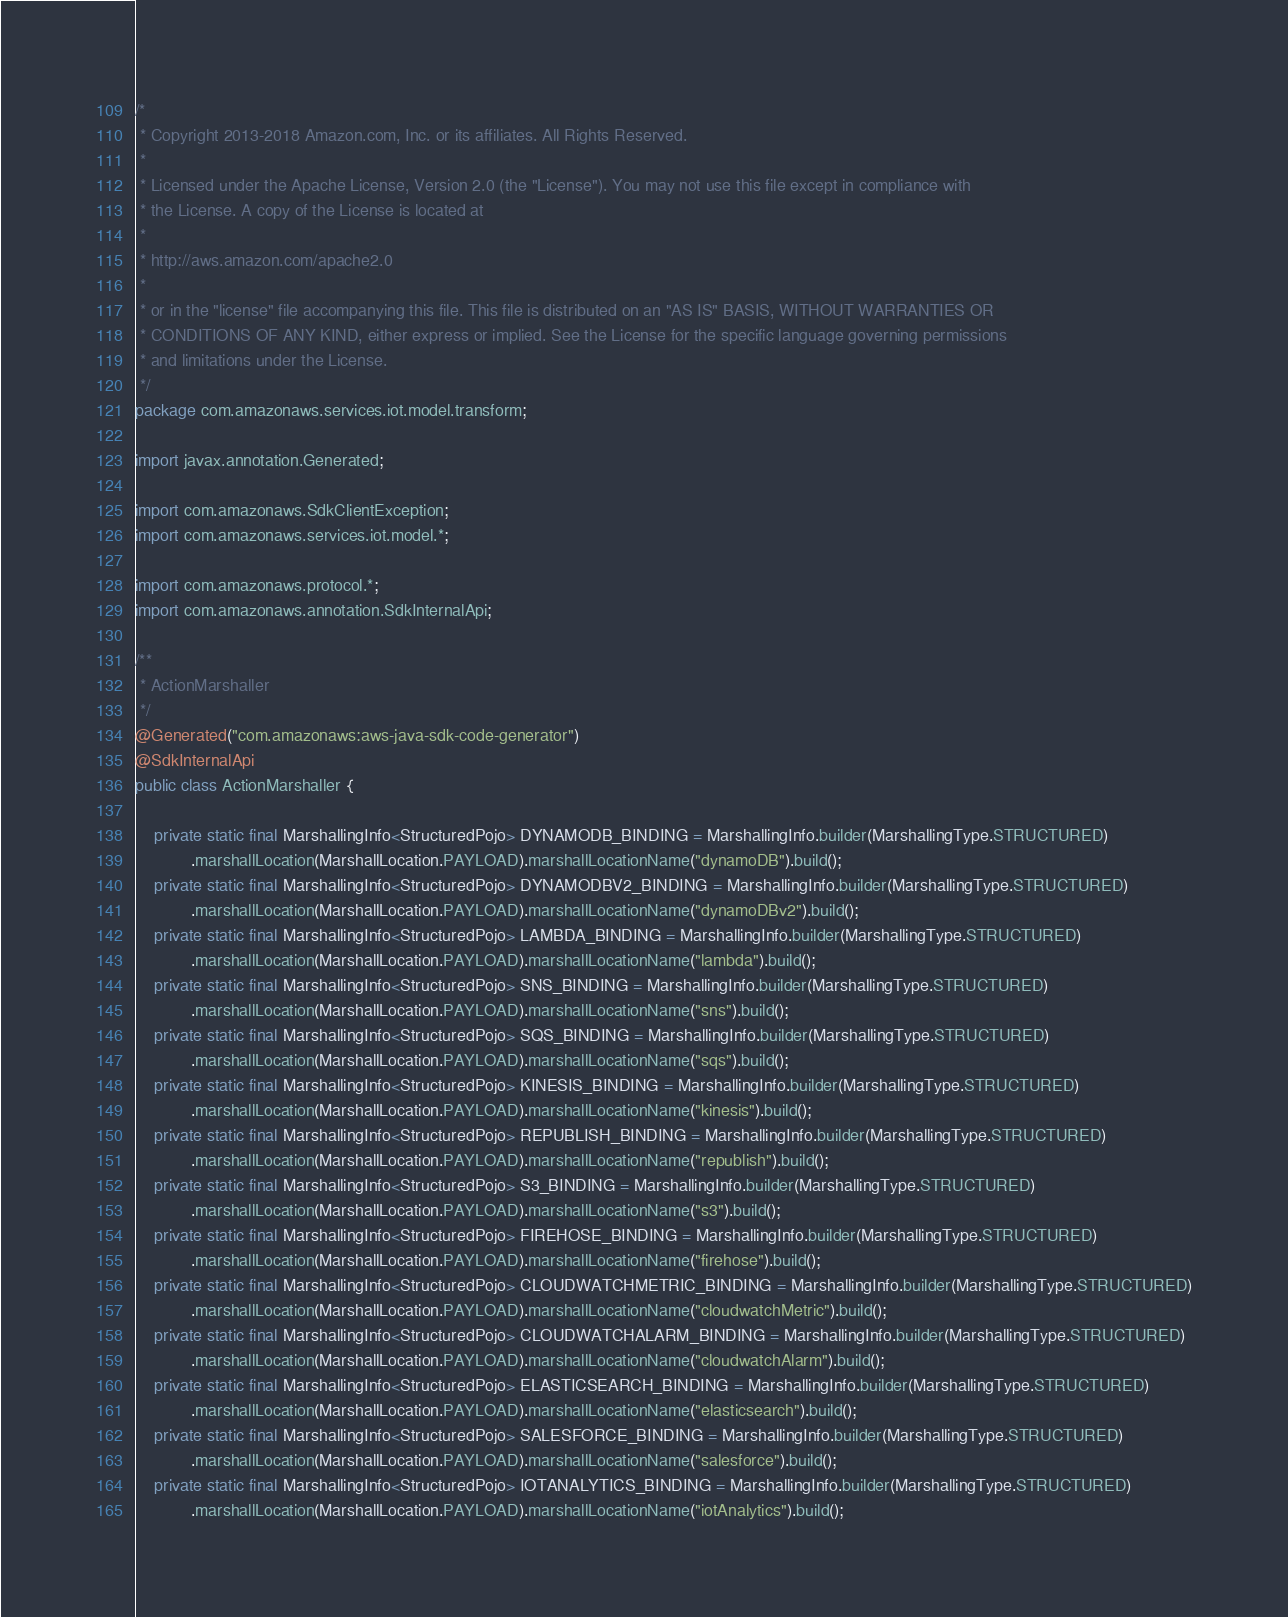Convert code to text. <code><loc_0><loc_0><loc_500><loc_500><_Java_>/*
 * Copyright 2013-2018 Amazon.com, Inc. or its affiliates. All Rights Reserved.
 * 
 * Licensed under the Apache License, Version 2.0 (the "License"). You may not use this file except in compliance with
 * the License. A copy of the License is located at
 * 
 * http://aws.amazon.com/apache2.0
 * 
 * or in the "license" file accompanying this file. This file is distributed on an "AS IS" BASIS, WITHOUT WARRANTIES OR
 * CONDITIONS OF ANY KIND, either express or implied. See the License for the specific language governing permissions
 * and limitations under the License.
 */
package com.amazonaws.services.iot.model.transform;

import javax.annotation.Generated;

import com.amazonaws.SdkClientException;
import com.amazonaws.services.iot.model.*;

import com.amazonaws.protocol.*;
import com.amazonaws.annotation.SdkInternalApi;

/**
 * ActionMarshaller
 */
@Generated("com.amazonaws:aws-java-sdk-code-generator")
@SdkInternalApi
public class ActionMarshaller {

    private static final MarshallingInfo<StructuredPojo> DYNAMODB_BINDING = MarshallingInfo.builder(MarshallingType.STRUCTURED)
            .marshallLocation(MarshallLocation.PAYLOAD).marshallLocationName("dynamoDB").build();
    private static final MarshallingInfo<StructuredPojo> DYNAMODBV2_BINDING = MarshallingInfo.builder(MarshallingType.STRUCTURED)
            .marshallLocation(MarshallLocation.PAYLOAD).marshallLocationName("dynamoDBv2").build();
    private static final MarshallingInfo<StructuredPojo> LAMBDA_BINDING = MarshallingInfo.builder(MarshallingType.STRUCTURED)
            .marshallLocation(MarshallLocation.PAYLOAD).marshallLocationName("lambda").build();
    private static final MarshallingInfo<StructuredPojo> SNS_BINDING = MarshallingInfo.builder(MarshallingType.STRUCTURED)
            .marshallLocation(MarshallLocation.PAYLOAD).marshallLocationName("sns").build();
    private static final MarshallingInfo<StructuredPojo> SQS_BINDING = MarshallingInfo.builder(MarshallingType.STRUCTURED)
            .marshallLocation(MarshallLocation.PAYLOAD).marshallLocationName("sqs").build();
    private static final MarshallingInfo<StructuredPojo> KINESIS_BINDING = MarshallingInfo.builder(MarshallingType.STRUCTURED)
            .marshallLocation(MarshallLocation.PAYLOAD).marshallLocationName("kinesis").build();
    private static final MarshallingInfo<StructuredPojo> REPUBLISH_BINDING = MarshallingInfo.builder(MarshallingType.STRUCTURED)
            .marshallLocation(MarshallLocation.PAYLOAD).marshallLocationName("republish").build();
    private static final MarshallingInfo<StructuredPojo> S3_BINDING = MarshallingInfo.builder(MarshallingType.STRUCTURED)
            .marshallLocation(MarshallLocation.PAYLOAD).marshallLocationName("s3").build();
    private static final MarshallingInfo<StructuredPojo> FIREHOSE_BINDING = MarshallingInfo.builder(MarshallingType.STRUCTURED)
            .marshallLocation(MarshallLocation.PAYLOAD).marshallLocationName("firehose").build();
    private static final MarshallingInfo<StructuredPojo> CLOUDWATCHMETRIC_BINDING = MarshallingInfo.builder(MarshallingType.STRUCTURED)
            .marshallLocation(MarshallLocation.PAYLOAD).marshallLocationName("cloudwatchMetric").build();
    private static final MarshallingInfo<StructuredPojo> CLOUDWATCHALARM_BINDING = MarshallingInfo.builder(MarshallingType.STRUCTURED)
            .marshallLocation(MarshallLocation.PAYLOAD).marshallLocationName("cloudwatchAlarm").build();
    private static final MarshallingInfo<StructuredPojo> ELASTICSEARCH_BINDING = MarshallingInfo.builder(MarshallingType.STRUCTURED)
            .marshallLocation(MarshallLocation.PAYLOAD).marshallLocationName("elasticsearch").build();
    private static final MarshallingInfo<StructuredPojo> SALESFORCE_BINDING = MarshallingInfo.builder(MarshallingType.STRUCTURED)
            .marshallLocation(MarshallLocation.PAYLOAD).marshallLocationName("salesforce").build();
    private static final MarshallingInfo<StructuredPojo> IOTANALYTICS_BINDING = MarshallingInfo.builder(MarshallingType.STRUCTURED)
            .marshallLocation(MarshallLocation.PAYLOAD).marshallLocationName("iotAnalytics").build();</code> 